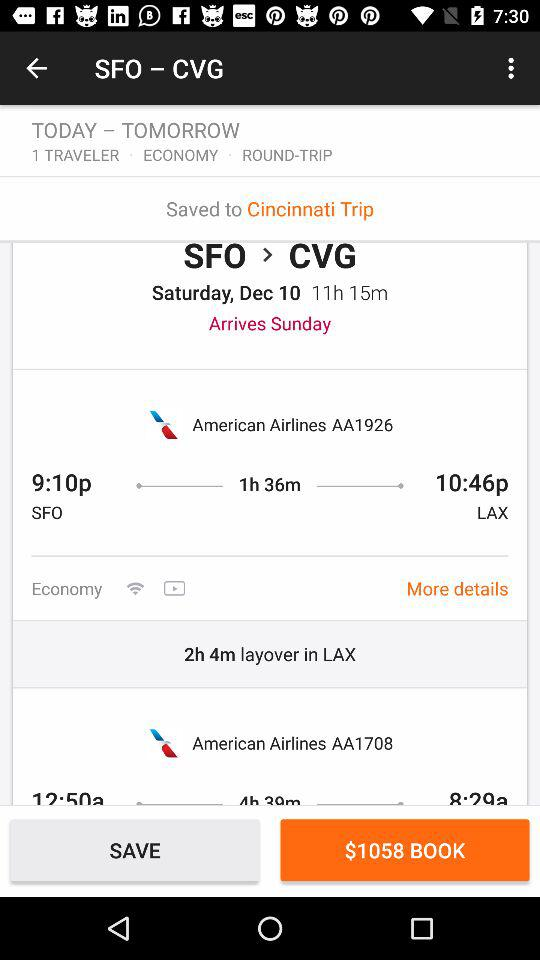What is the number of travelers? The number of travelers is 1. 